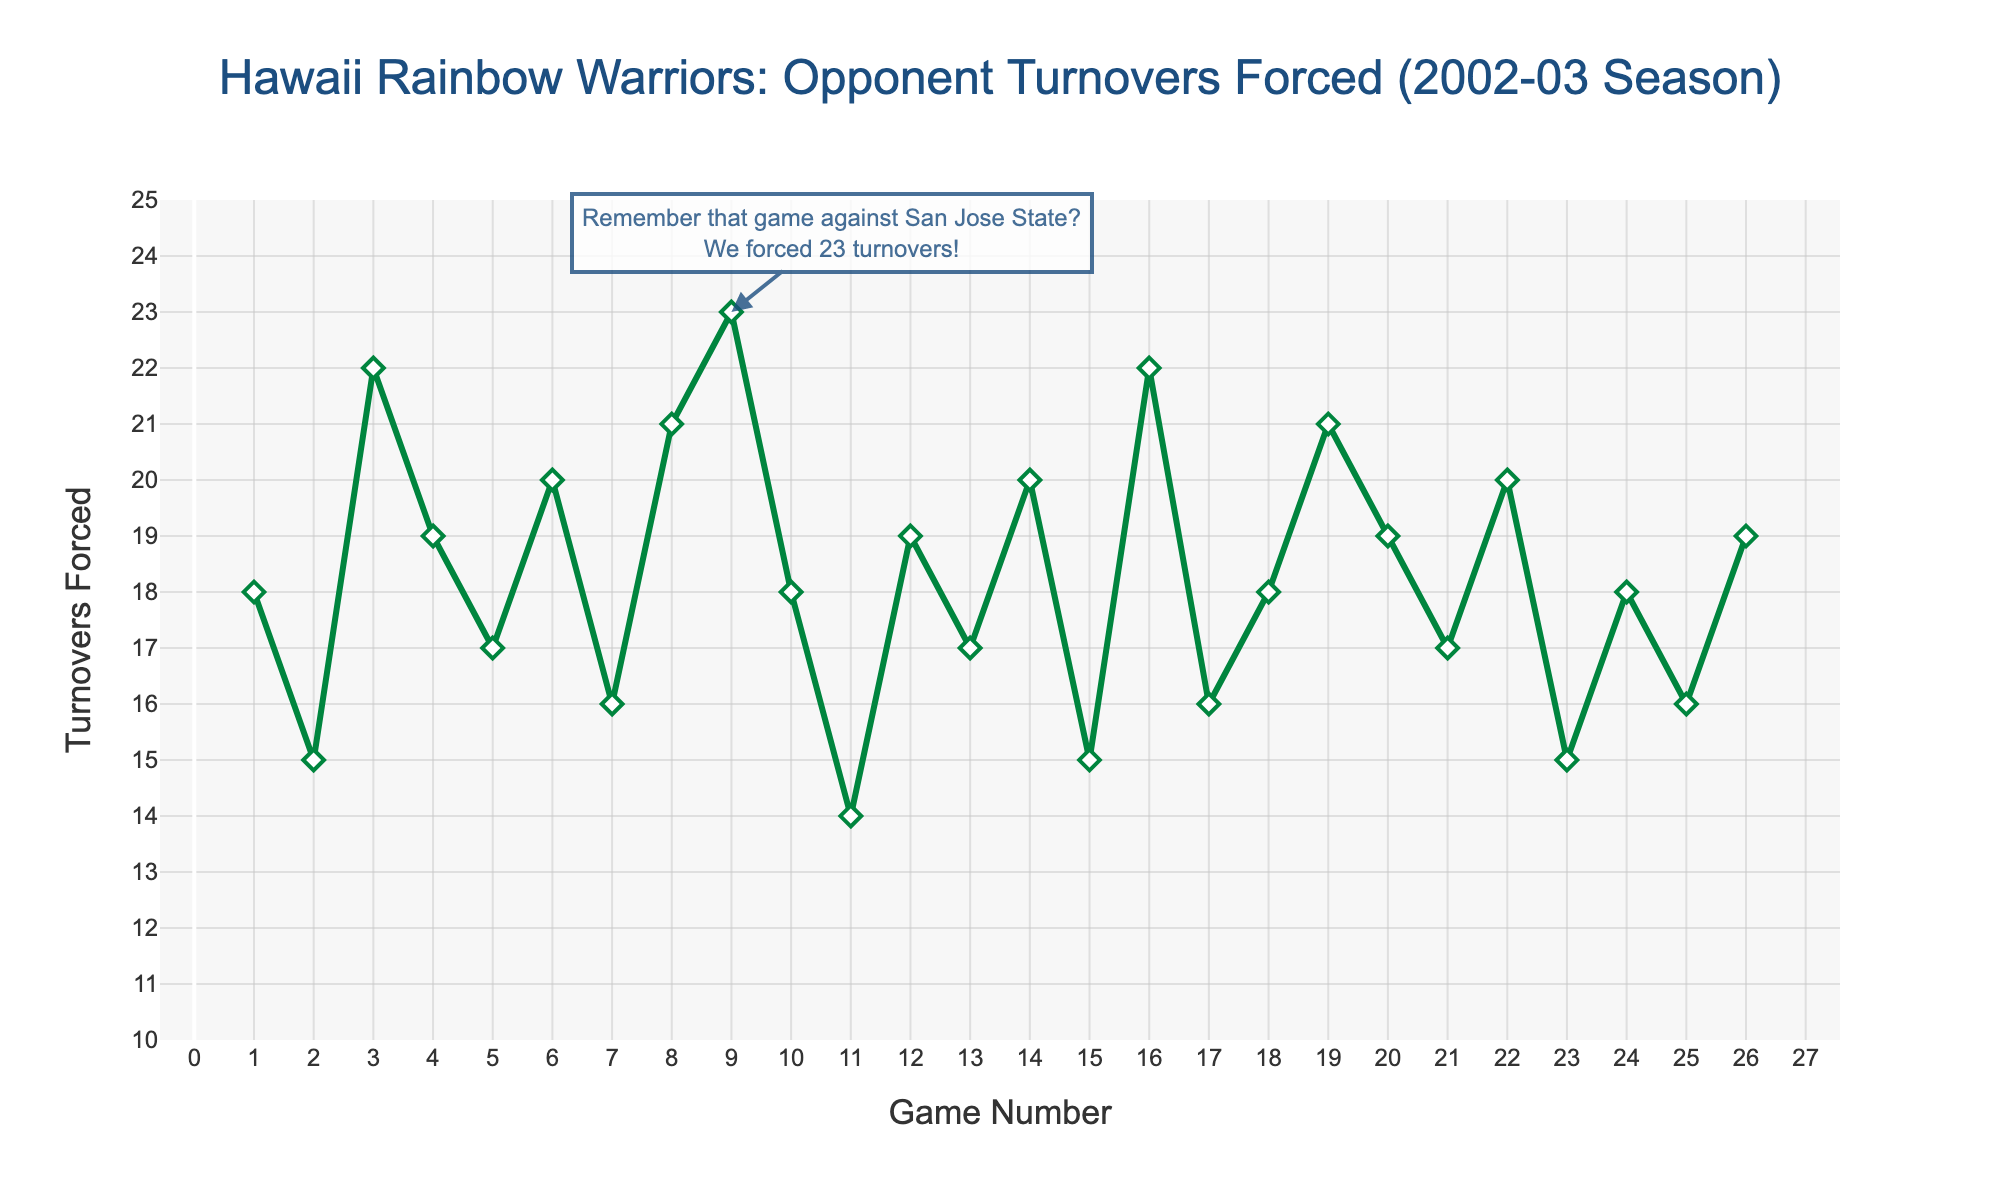What was the highest number of turnovers forced in a single game? The highest number is visually the tallest point on the line chart. Identifying the highest point, it aligns with Game 9 against San Jose State where 23 turnovers were forced.
Answer: 23 On average, how many turnovers did Hawaii force per game during the season? Summing up all turnovers from Game 1 to Game 26 (18 + 15 + 22 + 19 + 17 + 20 + 16 + 21 + 23 + 18 + 14 + 19 + 17 + 20 + 15 + 22 + 16 + 18 + 21 + 19 + 17 + 20 + 15 + 18 + 16 + 19 = 456) and dividing by 26 games yields the average.
Answer: 17.54 Did Hawaii force more turnovers in the first half or the second half of the regular season? The regular season has 22 games, so splitting into first half (Game 1 to Game 11) and second half (Game 12 to Game 22): First half sums up to 188 (18+15+22+19+17+20+16+21+23+18+14) and second half to 196 (19+17+20+15+22+16+18+21+19+17+20).
Answer: Second half How many games had 20 or more turnovers forced? Count the points on the graph where the turnover values are 20 or greater. These occur at Games 3, 6, 8, 9, 14, 16, 19, 22, 24, and 26.
Answer: 10 Which game saw the fewest turnovers forced by Hawaii? The shortest point on the line represents the fewest turnovers. This happens in Game 11 against Nevada with 14 turnovers forced.
Answer: Game 11 Were there any games where Hawaii forced an equal number of turnovers twice against the same opponent? Checking each pair of games against the same opponent, it can be seen that Games 2 and 15 against Fresno State both have 15 turnovers forced, and Games 12 and 26 against Tulsa each have 19 turnovers.
Answer: Yes How did the turnovers forced trend from Game 20 to the end of the season? Observing the line chart from point corresponding to Game 20 to Game 26, the numbers fluctuate but end higher than they started: 19, 17, 20, 15, 18, 16, 19. Overall, a slight rise is noted if visualized.
Answer: Slightly upward What was the difference in turnovers forced between the game with the highest turnovers and the game with the lowest? The highest turnovers forced were 23 and the lowest were 14. Calculating the difference yields 23 - 14 = 9.
Answer: 9 Did any opponent's turnovers stay consistent across multiple games against Hawaii? Reviewing the matchups shows that Fresno State had turnovers of 16 and 15 in two separate games, not consistent but close. Same observation for Nevada with 14 and 16. No consistent turnovers across multiple matches.
Answer: No If Hawaii's goal was to force at least 18 turnovers per game, how many games met this target? Counting the points where turnovers forced are 18 or more within the figure, we see 15 such games.
Answer: 15 